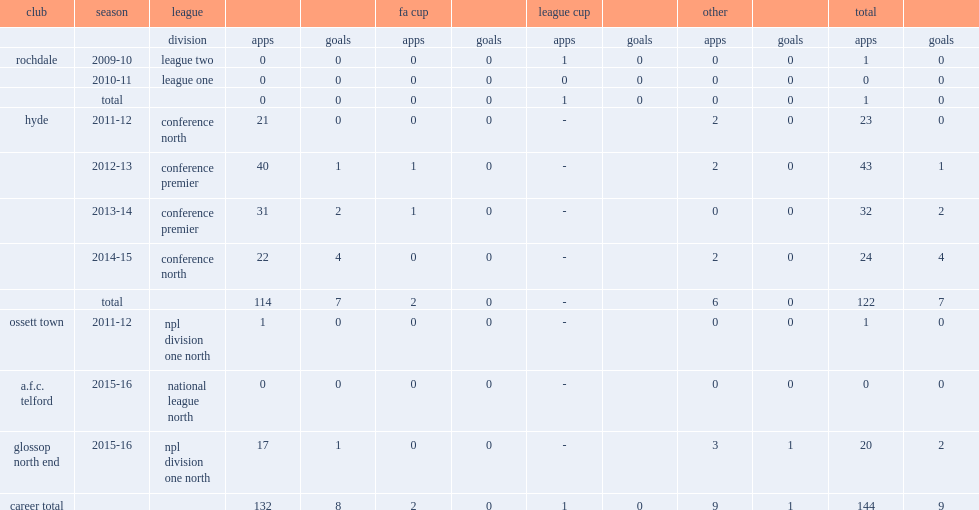In the 2012-13 season, which league did josh brizell make his first appearance with hyde? Conference premier. 